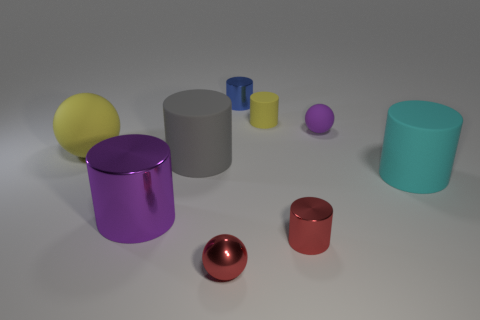Subtract 2 cylinders. How many cylinders are left? 4 Subtract all yellow cylinders. How many cylinders are left? 5 Subtract all purple cylinders. How many cylinders are left? 5 Subtract all cyan cylinders. Subtract all gray cubes. How many cylinders are left? 5 Add 1 small blue cylinders. How many objects exist? 10 Subtract all cylinders. How many objects are left? 3 Add 2 cylinders. How many cylinders exist? 8 Subtract 0 gray spheres. How many objects are left? 9 Subtract all small red metal things. Subtract all large purple shiny cylinders. How many objects are left? 6 Add 1 large yellow balls. How many large yellow balls are left? 2 